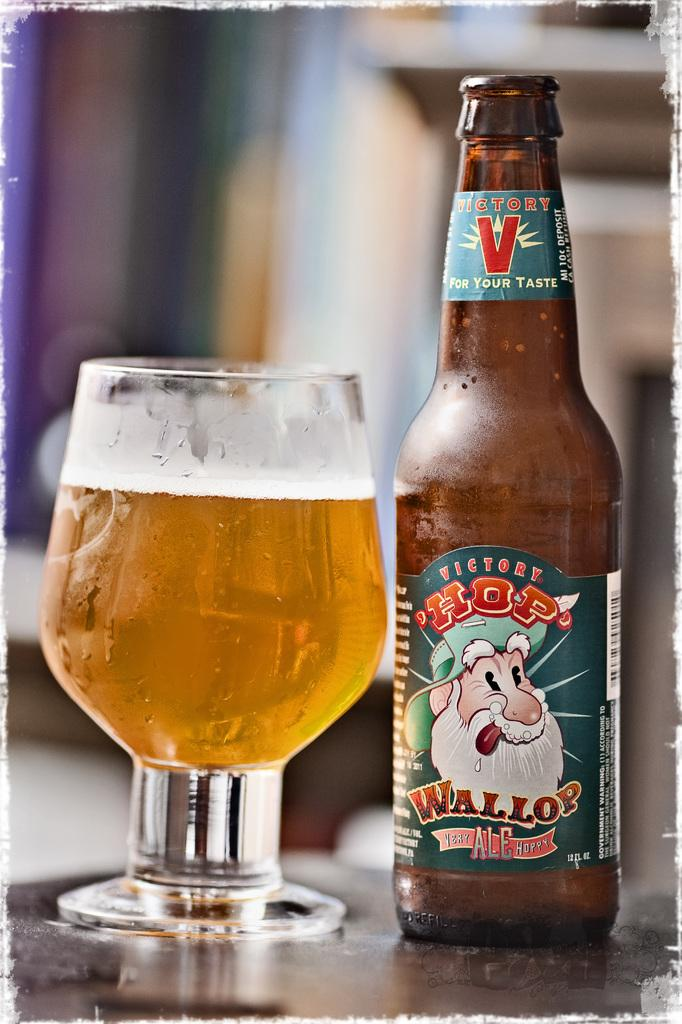<image>
Describe the image concisely. A full glass with a bottle that has Wallop written on it. 